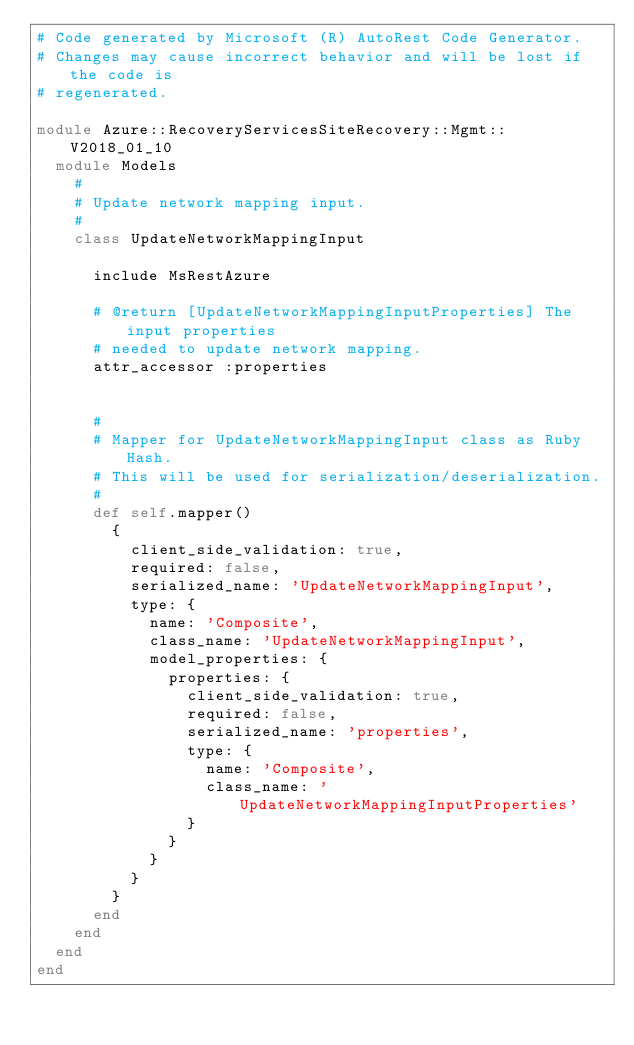<code> <loc_0><loc_0><loc_500><loc_500><_Ruby_># Code generated by Microsoft (R) AutoRest Code Generator.
# Changes may cause incorrect behavior and will be lost if the code is
# regenerated.

module Azure::RecoveryServicesSiteRecovery::Mgmt::V2018_01_10
  module Models
    #
    # Update network mapping input.
    #
    class UpdateNetworkMappingInput

      include MsRestAzure

      # @return [UpdateNetworkMappingInputProperties] The input properties
      # needed to update network mapping.
      attr_accessor :properties


      #
      # Mapper for UpdateNetworkMappingInput class as Ruby Hash.
      # This will be used for serialization/deserialization.
      #
      def self.mapper()
        {
          client_side_validation: true,
          required: false,
          serialized_name: 'UpdateNetworkMappingInput',
          type: {
            name: 'Composite',
            class_name: 'UpdateNetworkMappingInput',
            model_properties: {
              properties: {
                client_side_validation: true,
                required: false,
                serialized_name: 'properties',
                type: {
                  name: 'Composite',
                  class_name: 'UpdateNetworkMappingInputProperties'
                }
              }
            }
          }
        }
      end
    end
  end
end
</code> 